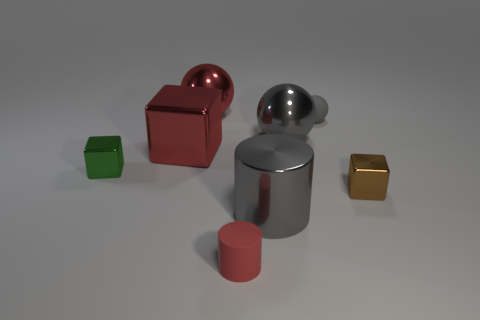There is a big sphere that is to the right of the big ball that is to the left of the small red thing; are there any metal spheres in front of it?
Provide a short and direct response. No. Is there anything else that is the same size as the brown block?
Provide a short and direct response. Yes. Is the shape of the tiny brown metal thing the same as the rubber object in front of the tiny green cube?
Ensure brevity in your answer.  No. What is the color of the metallic sphere that is left of the gray sphere left of the tiny thing that is behind the gray metallic ball?
Provide a short and direct response. Red. What number of objects are small metallic cubes to the left of the tiny red rubber cylinder or small things right of the gray shiny cylinder?
Keep it short and to the point. 3. How many other objects are the same color as the big metallic block?
Your response must be concise. 2. Does the red thing that is in front of the big metal block have the same shape as the small green metal object?
Your answer should be very brief. No. Is the number of large red shiny spheres that are in front of the small green metal block less than the number of small brown matte objects?
Provide a short and direct response. No. Is there a tiny green sphere made of the same material as the large gray ball?
Keep it short and to the point. No. What is the material of the red cylinder that is the same size as the green shiny thing?
Keep it short and to the point. Rubber. 